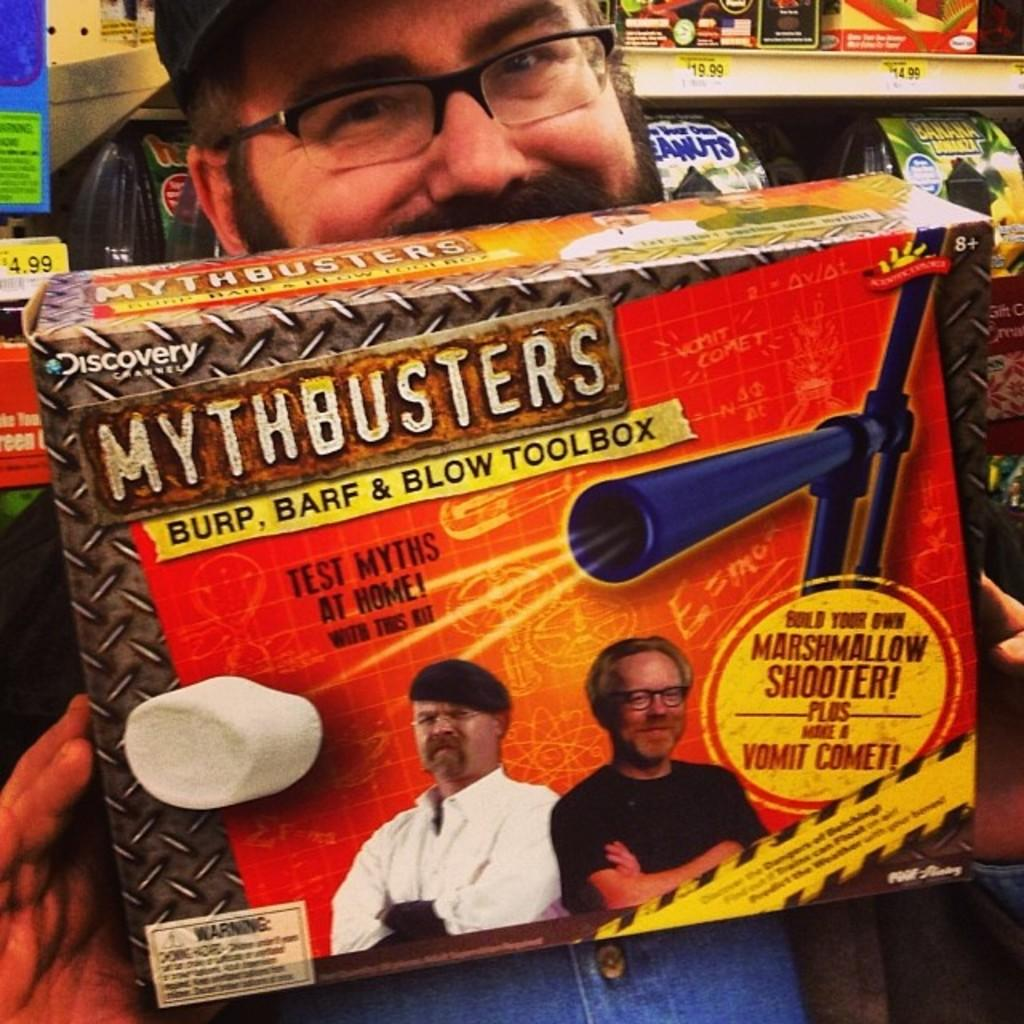What can be seen in the image? There is a person in the image. Can you describe the person's appearance? The person is wearing spectacles and a cap. What is the person holding in his hand? The person is holding a box in his hand. What is visible in the background of the image? There is a group of items placed in a rack in the background of the image. How does the person express anger in the image? There is no indication of anger in the image; the person's facial expression is not visible. Can you see any worms in the image? There are no worms present in the image. 